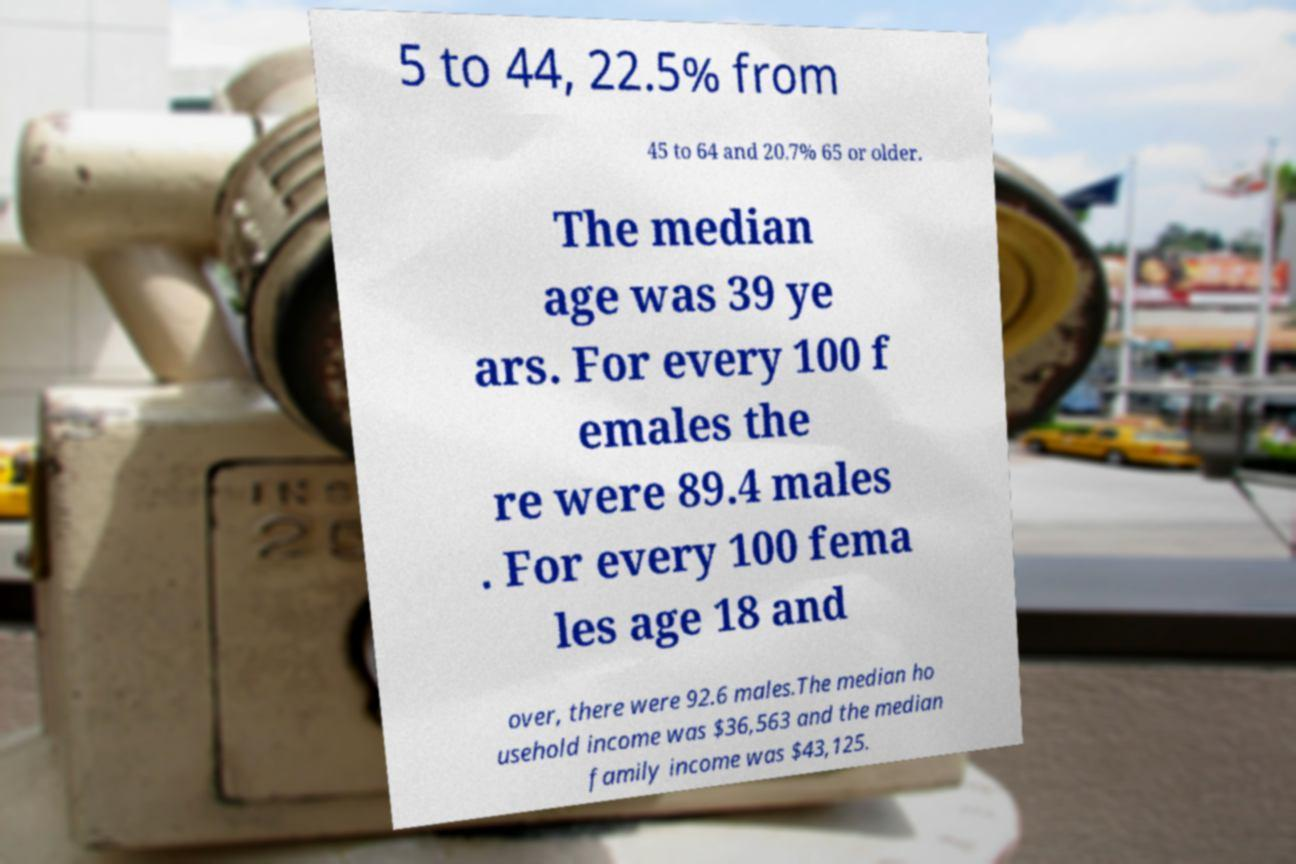Can you read and provide the text displayed in the image?This photo seems to have some interesting text. Can you extract and type it out for me? 5 to 44, 22.5% from 45 to 64 and 20.7% 65 or older. The median age was 39 ye ars. For every 100 f emales the re were 89.4 males . For every 100 fema les age 18 and over, there were 92.6 males.The median ho usehold income was $36,563 and the median family income was $43,125. 